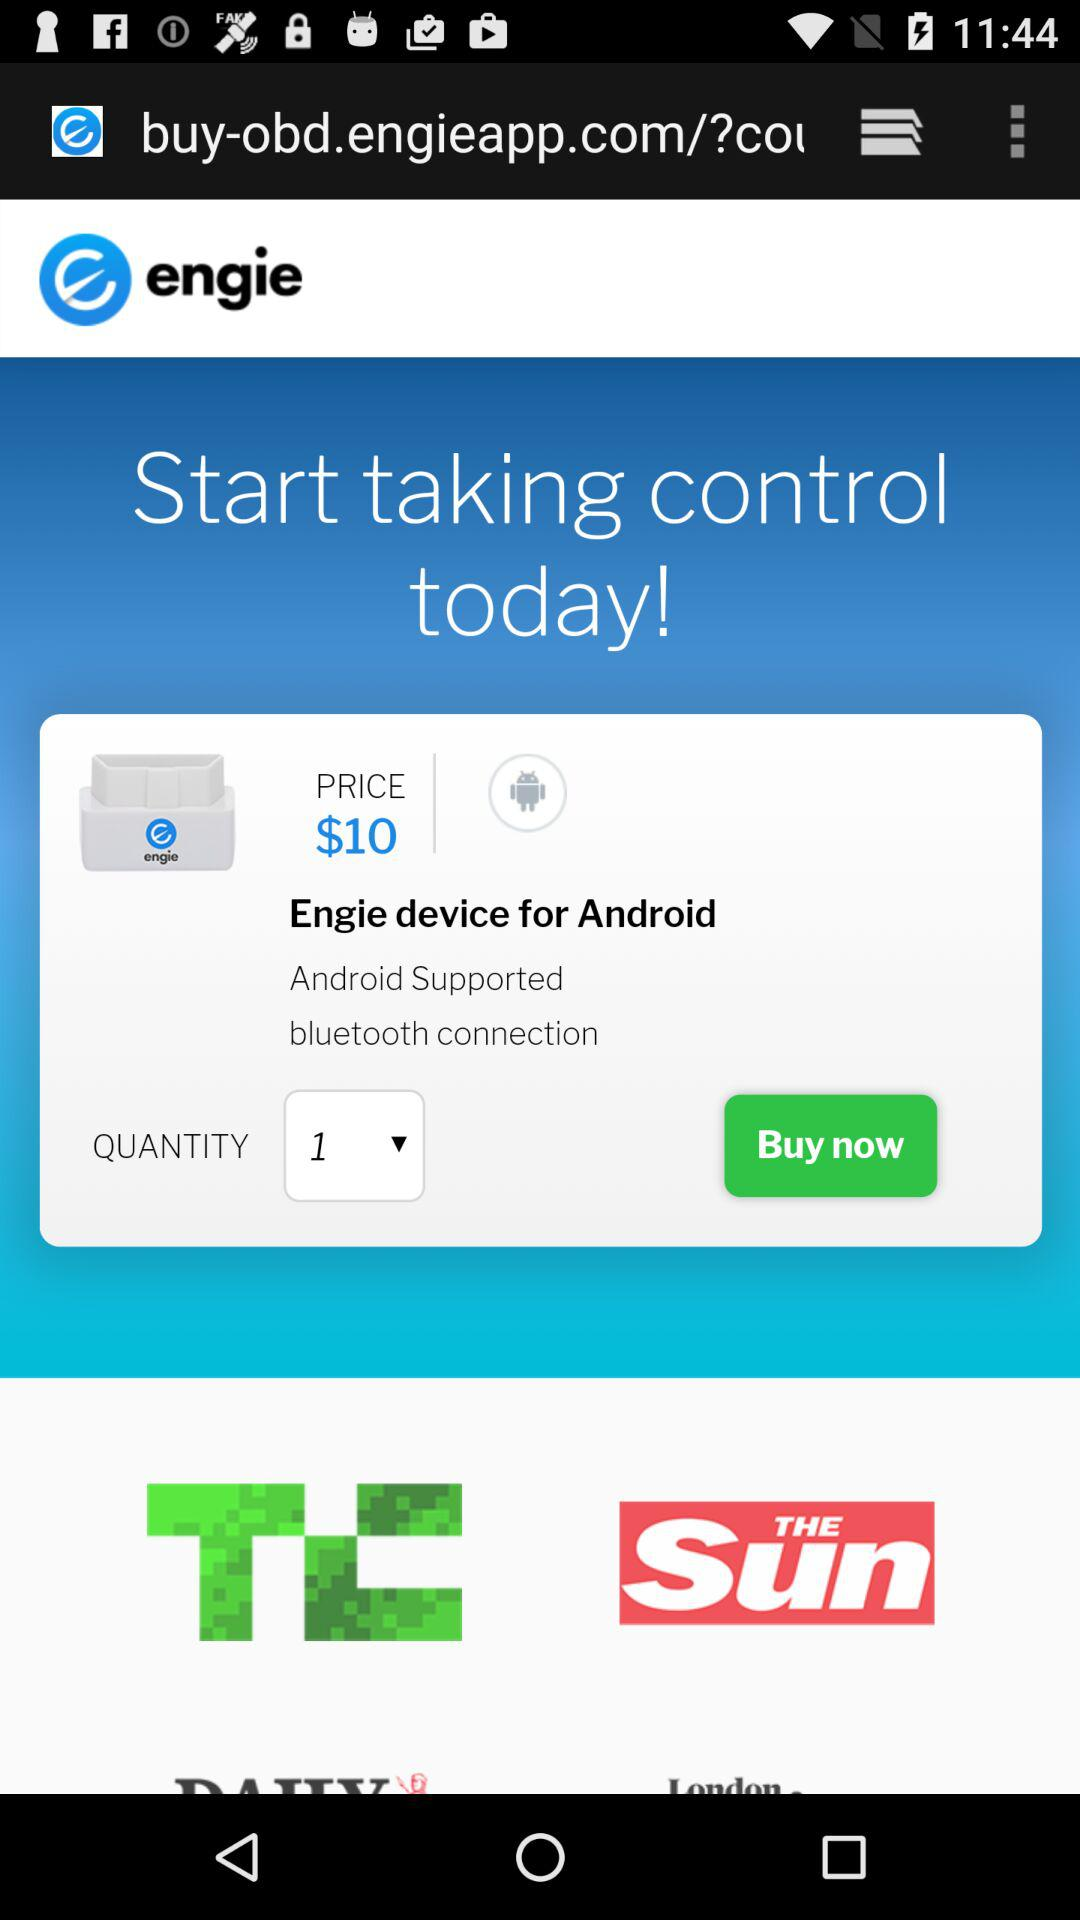What's the supported system? The supported system is Android. 